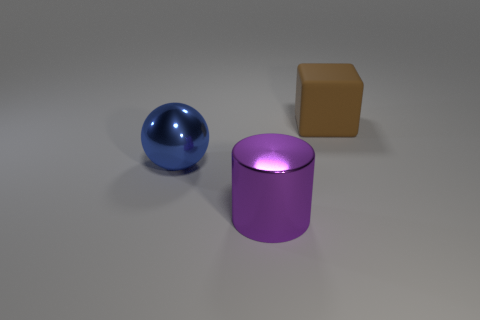Add 2 balls. How many objects exist? 5 Subtract all blocks. How many objects are left? 2 Subtract 0 green cylinders. How many objects are left? 3 Subtract all metallic spheres. Subtract all tiny yellow rubber blocks. How many objects are left? 2 Add 1 blue metal objects. How many blue metal objects are left? 2 Add 3 blue spheres. How many blue spheres exist? 4 